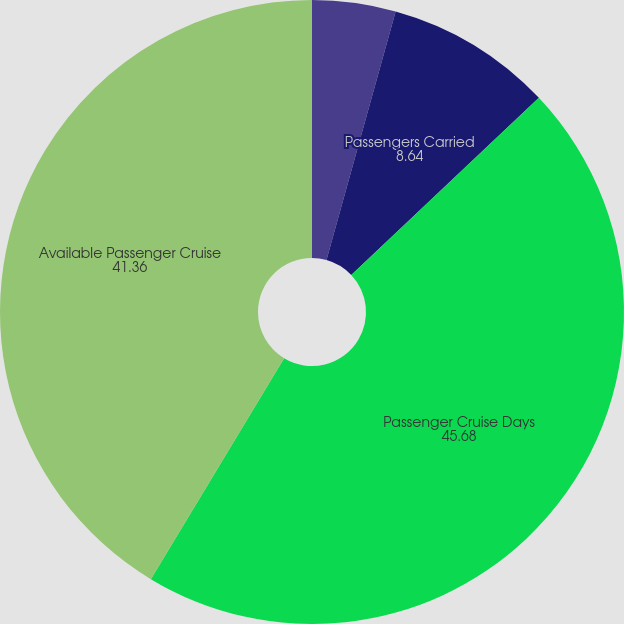Convert chart. <chart><loc_0><loc_0><loc_500><loc_500><pie_chart><fcel>Year Ended December 31<fcel>Passengers Carried<fcel>Passenger Cruise Days<fcel>Available Passenger Cruise<fcel>Occupancy<nl><fcel>4.32%<fcel>8.64%<fcel>45.68%<fcel>41.36%<fcel>0.0%<nl></chart> 